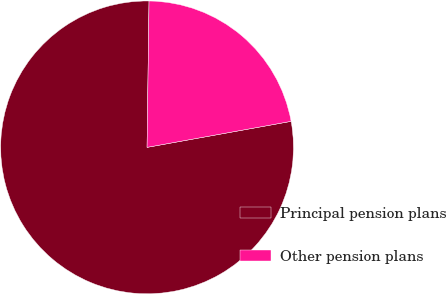Convert chart. <chart><loc_0><loc_0><loc_500><loc_500><pie_chart><fcel>Principal pension plans<fcel>Other pension plans<nl><fcel>78.06%<fcel>21.94%<nl></chart> 